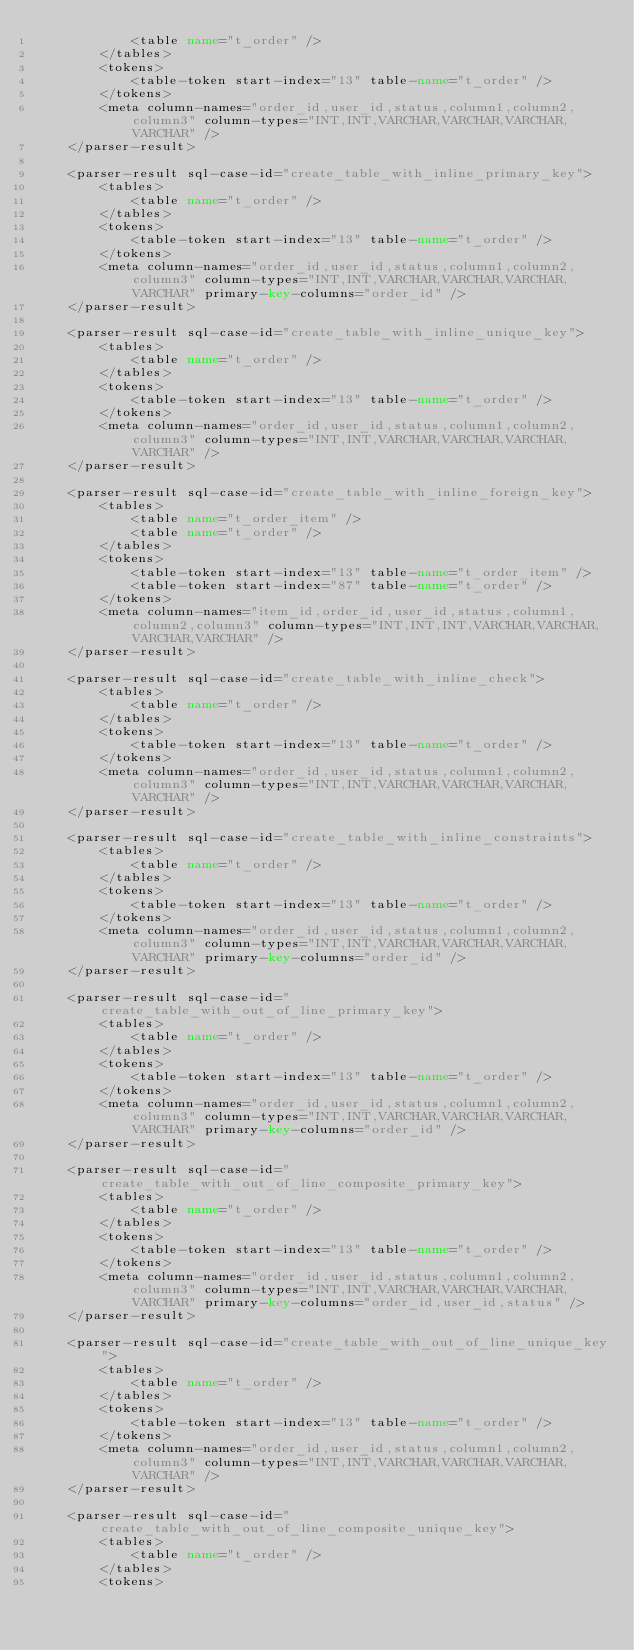<code> <loc_0><loc_0><loc_500><loc_500><_XML_>            <table name="t_order" />
        </tables>
        <tokens>
            <table-token start-index="13" table-name="t_order" />
        </tokens>
        <meta column-names="order_id,user_id,status,column1,column2,column3" column-types="INT,INT,VARCHAR,VARCHAR,VARCHAR,VARCHAR" />
    </parser-result>
    
    <parser-result sql-case-id="create_table_with_inline_primary_key">
        <tables>
            <table name="t_order" />
        </tables>
        <tokens>
            <table-token start-index="13" table-name="t_order" />
        </tokens>
        <meta column-names="order_id,user_id,status,column1,column2,column3" column-types="INT,INT,VARCHAR,VARCHAR,VARCHAR,VARCHAR" primary-key-columns="order_id" />
    </parser-result>
    
    <parser-result sql-case-id="create_table_with_inline_unique_key">
        <tables>
            <table name="t_order" />
        </tables>
        <tokens>
            <table-token start-index="13" table-name="t_order" />
        </tokens>
        <meta column-names="order_id,user_id,status,column1,column2,column3" column-types="INT,INT,VARCHAR,VARCHAR,VARCHAR,VARCHAR" />
    </parser-result>
    
    <parser-result sql-case-id="create_table_with_inline_foreign_key">
        <tables>
            <table name="t_order_item" />
            <table name="t_order" />
        </tables>
        <tokens>
            <table-token start-index="13" table-name="t_order_item" />
            <table-token start-index="87" table-name="t_order" />
        </tokens>
        <meta column-names="item_id,order_id,user_id,status,column1,column2,column3" column-types="INT,INT,INT,VARCHAR,VARCHAR,VARCHAR,VARCHAR" />
    </parser-result>
    
    <parser-result sql-case-id="create_table_with_inline_check">
        <tables>
            <table name="t_order" />
        </tables>
        <tokens>
            <table-token start-index="13" table-name="t_order" />
        </tokens>
        <meta column-names="order_id,user_id,status,column1,column2,column3" column-types="INT,INT,VARCHAR,VARCHAR,VARCHAR,VARCHAR" />
    </parser-result>
    
    <parser-result sql-case-id="create_table_with_inline_constraints">
        <tables>
            <table name="t_order" />
        </tables>
        <tokens>
            <table-token start-index="13" table-name="t_order" />
        </tokens>
        <meta column-names="order_id,user_id,status,column1,column2,column3" column-types="INT,INT,VARCHAR,VARCHAR,VARCHAR,VARCHAR" primary-key-columns="order_id" />
    </parser-result>
    
    <parser-result sql-case-id="create_table_with_out_of_line_primary_key">
        <tables>
            <table name="t_order" />
        </tables>
        <tokens>
            <table-token start-index="13" table-name="t_order" />
        </tokens>
        <meta column-names="order_id,user_id,status,column1,column2,column3" column-types="INT,INT,VARCHAR,VARCHAR,VARCHAR,VARCHAR" primary-key-columns="order_id" />
    </parser-result>
    
    <parser-result sql-case-id="create_table_with_out_of_line_composite_primary_key">
        <tables>
            <table name="t_order" />
        </tables>
        <tokens>
            <table-token start-index="13" table-name="t_order" />
        </tokens>
        <meta column-names="order_id,user_id,status,column1,column2,column3" column-types="INT,INT,VARCHAR,VARCHAR,VARCHAR,VARCHAR" primary-key-columns="order_id,user_id,status" />
    </parser-result>
    
    <parser-result sql-case-id="create_table_with_out_of_line_unique_key">
        <tables>
            <table name="t_order" />
        </tables>
        <tokens>
            <table-token start-index="13" table-name="t_order" />
        </tokens>
        <meta column-names="order_id,user_id,status,column1,column2,column3" column-types="INT,INT,VARCHAR,VARCHAR,VARCHAR,VARCHAR" />
    </parser-result>
    
    <parser-result sql-case-id="create_table_with_out_of_line_composite_unique_key">
        <tables>
            <table name="t_order" />
        </tables>
        <tokens></code> 